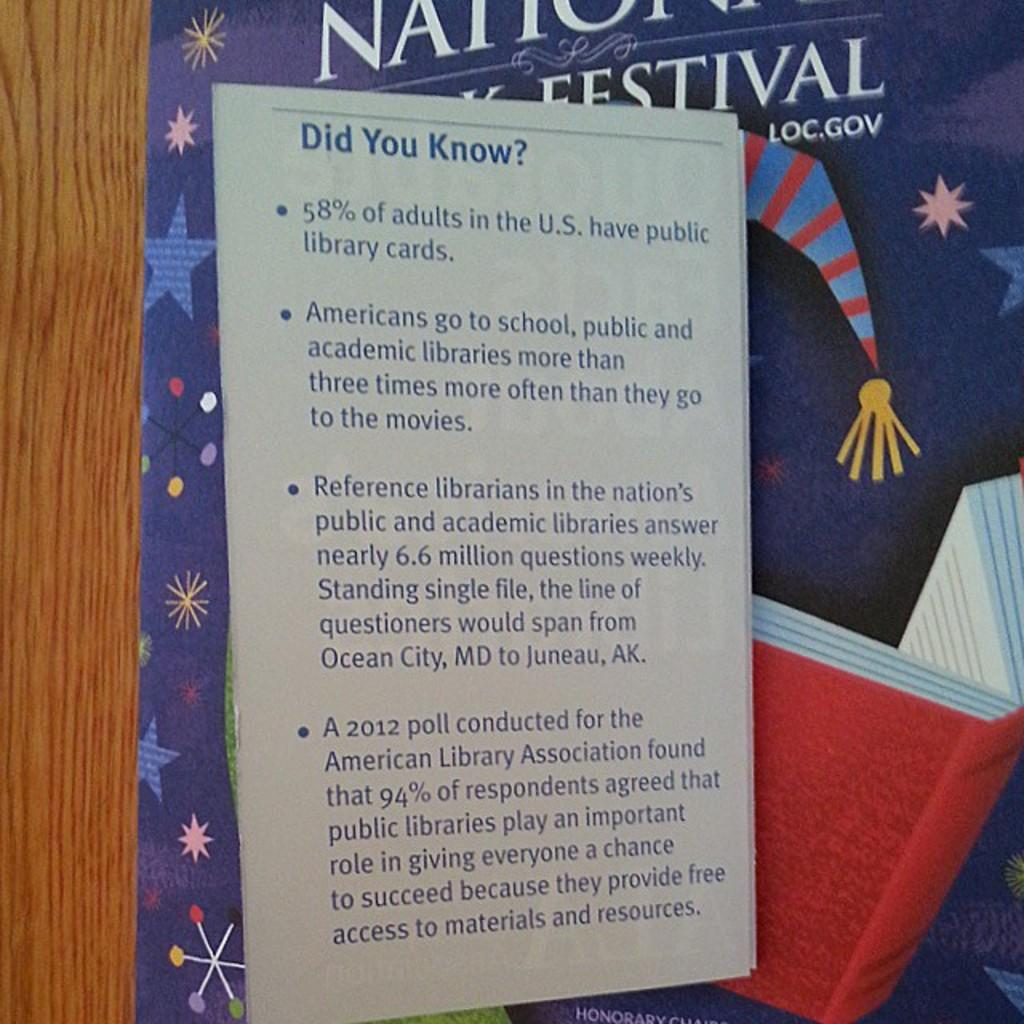<image>
Present a compact description of the photo's key features. According to the poster, 58% of adults in the U.S. have public library cards. 